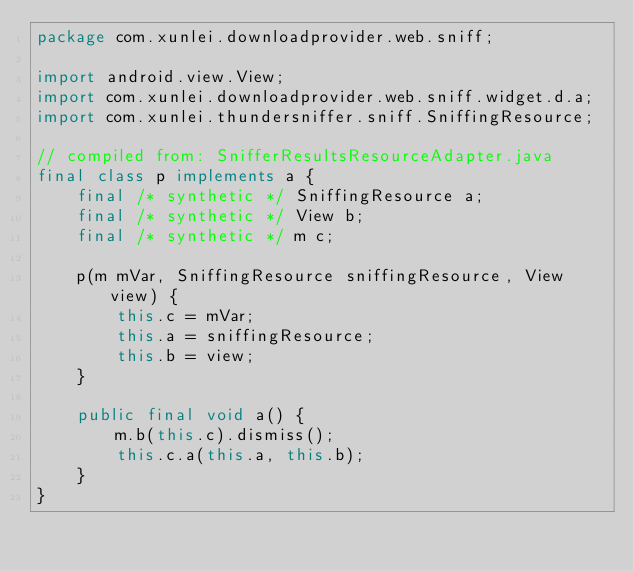Convert code to text. <code><loc_0><loc_0><loc_500><loc_500><_Java_>package com.xunlei.downloadprovider.web.sniff;

import android.view.View;
import com.xunlei.downloadprovider.web.sniff.widget.d.a;
import com.xunlei.thundersniffer.sniff.SniffingResource;

// compiled from: SnifferResultsResourceAdapter.java
final class p implements a {
    final /* synthetic */ SniffingResource a;
    final /* synthetic */ View b;
    final /* synthetic */ m c;

    p(m mVar, SniffingResource sniffingResource, View view) {
        this.c = mVar;
        this.a = sniffingResource;
        this.b = view;
    }

    public final void a() {
        m.b(this.c).dismiss();
        this.c.a(this.a, this.b);
    }
}
</code> 